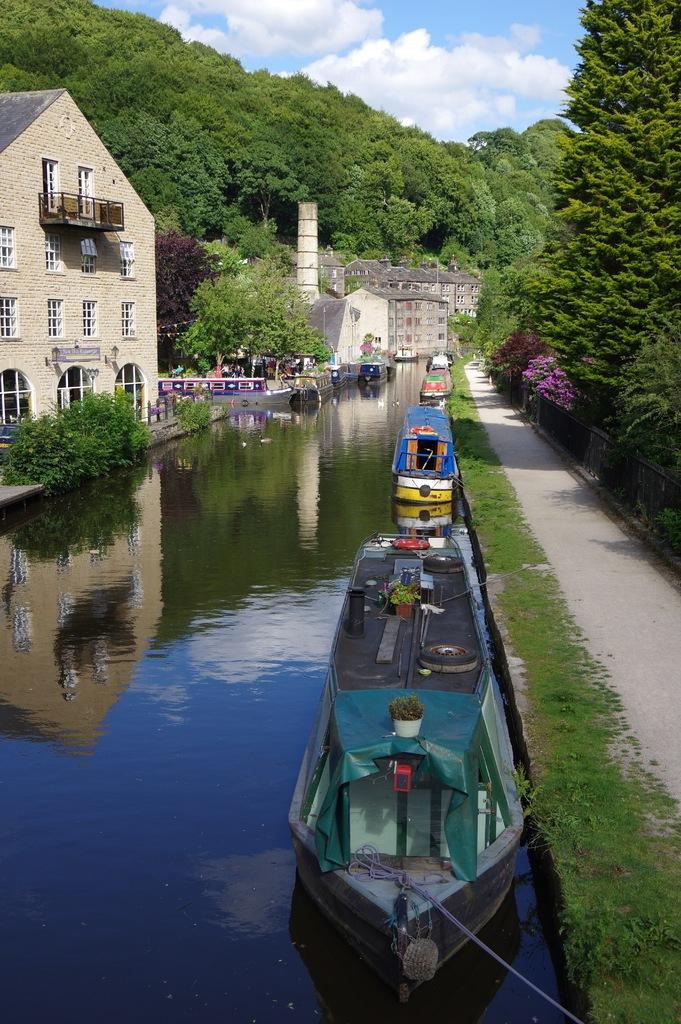What body of water is present in the image? There is a river in the image. What is on the river? There are boats on the river. What type of vegetation is near the river? There are trees around the river. What structures are located near the river? There are buildings around the river. What type of music can be heard coming from the river in the image? There is no indication of music in the image, as it features a river with boats, trees, and buildings. 